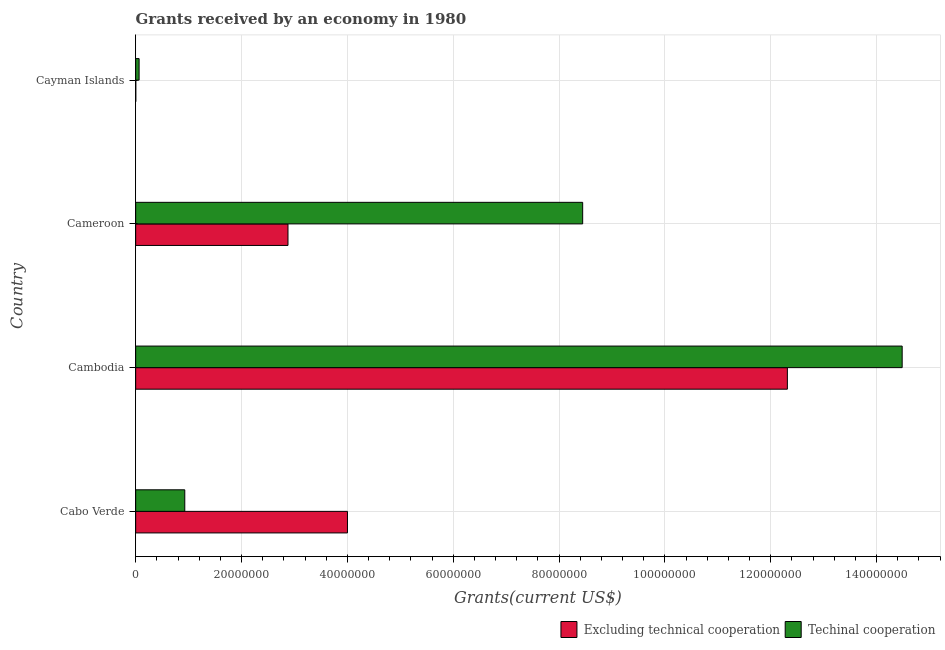How many groups of bars are there?
Provide a short and direct response. 4. Are the number of bars on each tick of the Y-axis equal?
Ensure brevity in your answer.  Yes. How many bars are there on the 1st tick from the top?
Your answer should be compact. 2. What is the label of the 3rd group of bars from the top?
Offer a very short reply. Cambodia. What is the amount of grants received(excluding technical cooperation) in Cabo Verde?
Your answer should be compact. 4.00e+07. Across all countries, what is the maximum amount of grants received(including technical cooperation)?
Offer a terse response. 1.45e+08. In which country was the amount of grants received(including technical cooperation) maximum?
Your answer should be compact. Cambodia. In which country was the amount of grants received(excluding technical cooperation) minimum?
Your answer should be very brief. Cayman Islands. What is the total amount of grants received(excluding technical cooperation) in the graph?
Make the answer very short. 1.92e+08. What is the difference between the amount of grants received(excluding technical cooperation) in Cabo Verde and that in Cameroon?
Your answer should be very brief. 1.12e+07. What is the difference between the amount of grants received(excluding technical cooperation) in Cambodia and the amount of grants received(including technical cooperation) in Cayman Islands?
Your answer should be very brief. 1.22e+08. What is the average amount of grants received(including technical cooperation) per country?
Offer a terse response. 5.98e+07. What is the difference between the amount of grants received(excluding technical cooperation) and amount of grants received(including technical cooperation) in Cameroon?
Give a very brief answer. -5.57e+07. In how many countries, is the amount of grants received(excluding technical cooperation) greater than 28000000 US$?
Keep it short and to the point. 3. What is the ratio of the amount of grants received(excluding technical cooperation) in Cambodia to that in Cameroon?
Provide a succinct answer. 4.28. Is the amount of grants received(excluding technical cooperation) in Cabo Verde less than that in Cameroon?
Provide a succinct answer. No. What is the difference between the highest and the second highest amount of grants received(excluding technical cooperation)?
Your answer should be very brief. 8.31e+07. What is the difference between the highest and the lowest amount of grants received(excluding technical cooperation)?
Your response must be concise. 1.23e+08. What does the 2nd bar from the top in Cabo Verde represents?
Your answer should be very brief. Excluding technical cooperation. What does the 2nd bar from the bottom in Cabo Verde represents?
Your answer should be very brief. Techinal cooperation. How many bars are there?
Ensure brevity in your answer.  8. Are all the bars in the graph horizontal?
Your answer should be very brief. Yes. How many countries are there in the graph?
Give a very brief answer. 4. What is the difference between two consecutive major ticks on the X-axis?
Your response must be concise. 2.00e+07. Are the values on the major ticks of X-axis written in scientific E-notation?
Give a very brief answer. No. Where does the legend appear in the graph?
Offer a very short reply. Bottom right. How many legend labels are there?
Your response must be concise. 2. What is the title of the graph?
Give a very brief answer. Grants received by an economy in 1980. What is the label or title of the X-axis?
Ensure brevity in your answer.  Grants(current US$). What is the Grants(current US$) in Excluding technical cooperation in Cabo Verde?
Make the answer very short. 4.00e+07. What is the Grants(current US$) of Techinal cooperation in Cabo Verde?
Offer a very short reply. 9.28e+06. What is the Grants(current US$) of Excluding technical cooperation in Cambodia?
Provide a short and direct response. 1.23e+08. What is the Grants(current US$) in Techinal cooperation in Cambodia?
Make the answer very short. 1.45e+08. What is the Grants(current US$) in Excluding technical cooperation in Cameroon?
Offer a terse response. 2.88e+07. What is the Grants(current US$) of Techinal cooperation in Cameroon?
Provide a short and direct response. 8.45e+07. What is the Grants(current US$) of Techinal cooperation in Cayman Islands?
Offer a terse response. 6.50e+05. Across all countries, what is the maximum Grants(current US$) of Excluding technical cooperation?
Make the answer very short. 1.23e+08. Across all countries, what is the maximum Grants(current US$) of Techinal cooperation?
Give a very brief answer. 1.45e+08. Across all countries, what is the minimum Grants(current US$) of Excluding technical cooperation?
Keep it short and to the point. 2.00e+04. Across all countries, what is the minimum Grants(current US$) of Techinal cooperation?
Offer a terse response. 6.50e+05. What is the total Grants(current US$) of Excluding technical cooperation in the graph?
Offer a terse response. 1.92e+08. What is the total Grants(current US$) of Techinal cooperation in the graph?
Provide a succinct answer. 2.39e+08. What is the difference between the Grants(current US$) in Excluding technical cooperation in Cabo Verde and that in Cambodia?
Your answer should be very brief. -8.31e+07. What is the difference between the Grants(current US$) of Techinal cooperation in Cabo Verde and that in Cambodia?
Offer a very short reply. -1.36e+08. What is the difference between the Grants(current US$) in Excluding technical cooperation in Cabo Verde and that in Cameroon?
Offer a terse response. 1.12e+07. What is the difference between the Grants(current US$) of Techinal cooperation in Cabo Verde and that in Cameroon?
Provide a succinct answer. -7.52e+07. What is the difference between the Grants(current US$) in Excluding technical cooperation in Cabo Verde and that in Cayman Islands?
Ensure brevity in your answer.  4.00e+07. What is the difference between the Grants(current US$) in Techinal cooperation in Cabo Verde and that in Cayman Islands?
Make the answer very short. 8.63e+06. What is the difference between the Grants(current US$) in Excluding technical cooperation in Cambodia and that in Cameroon?
Provide a short and direct response. 9.44e+07. What is the difference between the Grants(current US$) in Techinal cooperation in Cambodia and that in Cameroon?
Keep it short and to the point. 6.04e+07. What is the difference between the Grants(current US$) of Excluding technical cooperation in Cambodia and that in Cayman Islands?
Keep it short and to the point. 1.23e+08. What is the difference between the Grants(current US$) in Techinal cooperation in Cambodia and that in Cayman Islands?
Give a very brief answer. 1.44e+08. What is the difference between the Grants(current US$) of Excluding technical cooperation in Cameroon and that in Cayman Islands?
Provide a succinct answer. 2.88e+07. What is the difference between the Grants(current US$) in Techinal cooperation in Cameroon and that in Cayman Islands?
Ensure brevity in your answer.  8.38e+07. What is the difference between the Grants(current US$) of Excluding technical cooperation in Cabo Verde and the Grants(current US$) of Techinal cooperation in Cambodia?
Make the answer very short. -1.05e+08. What is the difference between the Grants(current US$) of Excluding technical cooperation in Cabo Verde and the Grants(current US$) of Techinal cooperation in Cameroon?
Ensure brevity in your answer.  -4.44e+07. What is the difference between the Grants(current US$) of Excluding technical cooperation in Cabo Verde and the Grants(current US$) of Techinal cooperation in Cayman Islands?
Your answer should be compact. 3.94e+07. What is the difference between the Grants(current US$) of Excluding technical cooperation in Cambodia and the Grants(current US$) of Techinal cooperation in Cameroon?
Offer a terse response. 3.87e+07. What is the difference between the Grants(current US$) in Excluding technical cooperation in Cambodia and the Grants(current US$) in Techinal cooperation in Cayman Islands?
Ensure brevity in your answer.  1.22e+08. What is the difference between the Grants(current US$) in Excluding technical cooperation in Cameroon and the Grants(current US$) in Techinal cooperation in Cayman Islands?
Your response must be concise. 2.81e+07. What is the average Grants(current US$) in Excluding technical cooperation per country?
Make the answer very short. 4.80e+07. What is the average Grants(current US$) in Techinal cooperation per country?
Provide a succinct answer. 5.98e+07. What is the difference between the Grants(current US$) of Excluding technical cooperation and Grants(current US$) of Techinal cooperation in Cabo Verde?
Make the answer very short. 3.07e+07. What is the difference between the Grants(current US$) of Excluding technical cooperation and Grants(current US$) of Techinal cooperation in Cambodia?
Give a very brief answer. -2.17e+07. What is the difference between the Grants(current US$) of Excluding technical cooperation and Grants(current US$) of Techinal cooperation in Cameroon?
Your answer should be very brief. -5.57e+07. What is the difference between the Grants(current US$) of Excluding technical cooperation and Grants(current US$) of Techinal cooperation in Cayman Islands?
Ensure brevity in your answer.  -6.30e+05. What is the ratio of the Grants(current US$) in Excluding technical cooperation in Cabo Verde to that in Cambodia?
Offer a terse response. 0.33. What is the ratio of the Grants(current US$) in Techinal cooperation in Cabo Verde to that in Cambodia?
Provide a short and direct response. 0.06. What is the ratio of the Grants(current US$) of Excluding technical cooperation in Cabo Verde to that in Cameroon?
Provide a short and direct response. 1.39. What is the ratio of the Grants(current US$) in Techinal cooperation in Cabo Verde to that in Cameroon?
Offer a terse response. 0.11. What is the ratio of the Grants(current US$) in Excluding technical cooperation in Cabo Verde to that in Cayman Islands?
Make the answer very short. 2001. What is the ratio of the Grants(current US$) in Techinal cooperation in Cabo Verde to that in Cayman Islands?
Offer a very short reply. 14.28. What is the ratio of the Grants(current US$) in Excluding technical cooperation in Cambodia to that in Cameroon?
Keep it short and to the point. 4.28. What is the ratio of the Grants(current US$) in Techinal cooperation in Cambodia to that in Cameroon?
Ensure brevity in your answer.  1.71. What is the ratio of the Grants(current US$) of Excluding technical cooperation in Cambodia to that in Cayman Islands?
Your response must be concise. 6157. What is the ratio of the Grants(current US$) of Techinal cooperation in Cambodia to that in Cayman Islands?
Your response must be concise. 222.82. What is the ratio of the Grants(current US$) in Excluding technical cooperation in Cameroon to that in Cayman Islands?
Keep it short and to the point. 1439. What is the ratio of the Grants(current US$) in Techinal cooperation in Cameroon to that in Cayman Islands?
Give a very brief answer. 129.94. What is the difference between the highest and the second highest Grants(current US$) of Excluding technical cooperation?
Provide a short and direct response. 8.31e+07. What is the difference between the highest and the second highest Grants(current US$) in Techinal cooperation?
Give a very brief answer. 6.04e+07. What is the difference between the highest and the lowest Grants(current US$) in Excluding technical cooperation?
Offer a terse response. 1.23e+08. What is the difference between the highest and the lowest Grants(current US$) in Techinal cooperation?
Your answer should be very brief. 1.44e+08. 